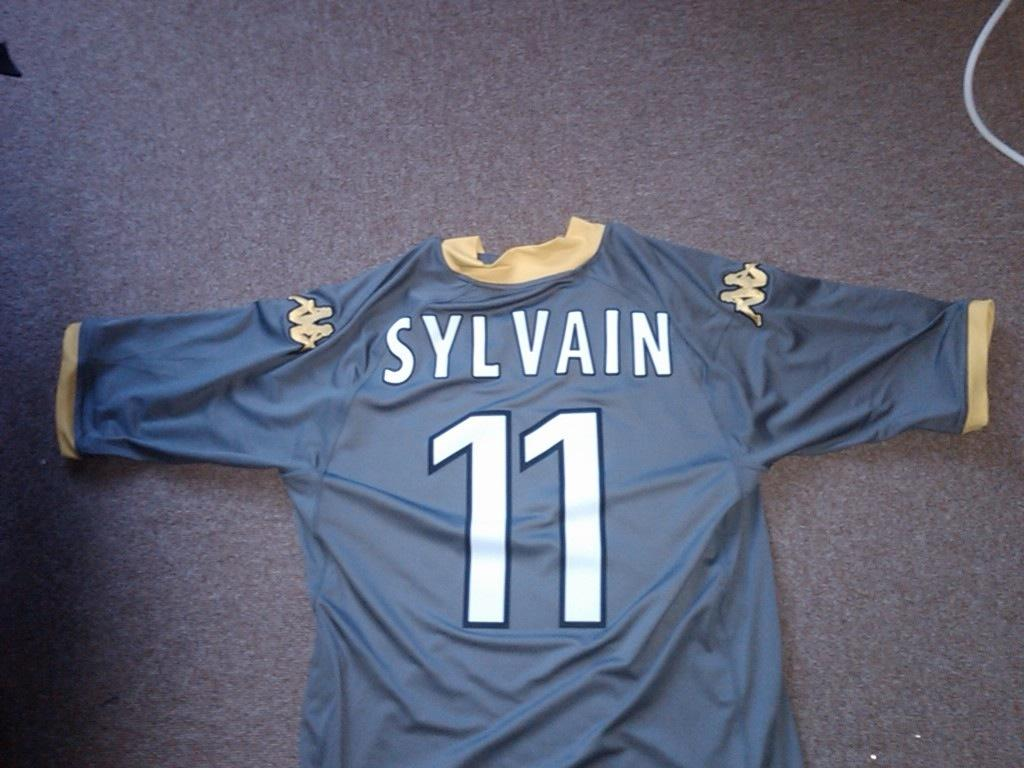<image>
Offer a succinct explanation of the picture presented. A jersey shirt, with the words Sylvain 11 on it. 